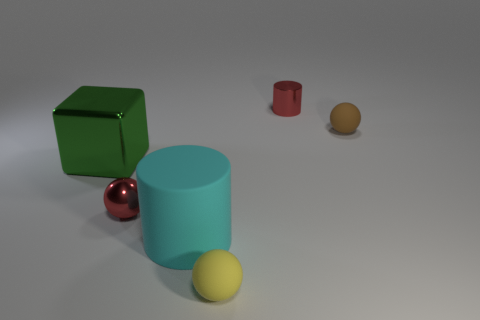There is a shiny ball that is to the left of the red object behind the ball that is on the right side of the small yellow rubber object; how big is it?
Keep it short and to the point. Small. How many purple things are tiny cylinders or matte objects?
Provide a succinct answer. 0. There is a red thing that is on the right side of the large cyan object; is it the same shape as the big matte object?
Your answer should be very brief. Yes. Is the number of metallic things right of the big green metallic block greater than the number of metallic spheres?
Ensure brevity in your answer.  Yes. How many red metallic cylinders have the same size as the red sphere?
Ensure brevity in your answer.  1. How many objects are either tiny yellow matte spheres or matte balls in front of the large green thing?
Ensure brevity in your answer.  1. What color is the small object that is right of the large matte cylinder and to the left of the red shiny cylinder?
Make the answer very short. Yellow. Is the size of the brown rubber object the same as the cyan object?
Give a very brief answer. No. What color is the matte ball in front of the brown matte thing?
Ensure brevity in your answer.  Yellow. Are there any small metallic cylinders that have the same color as the large metal object?
Provide a succinct answer. No. 